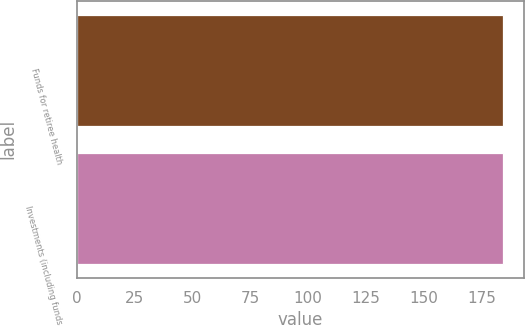Convert chart. <chart><loc_0><loc_0><loc_500><loc_500><bar_chart><fcel>Funds for retiree health<fcel>Investments (including funds<nl><fcel>184<fcel>184.1<nl></chart> 